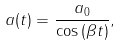<formula> <loc_0><loc_0><loc_500><loc_500>a ( t ) = \frac { a _ { 0 } } { \cos { ( \beta t ) } } ,</formula> 